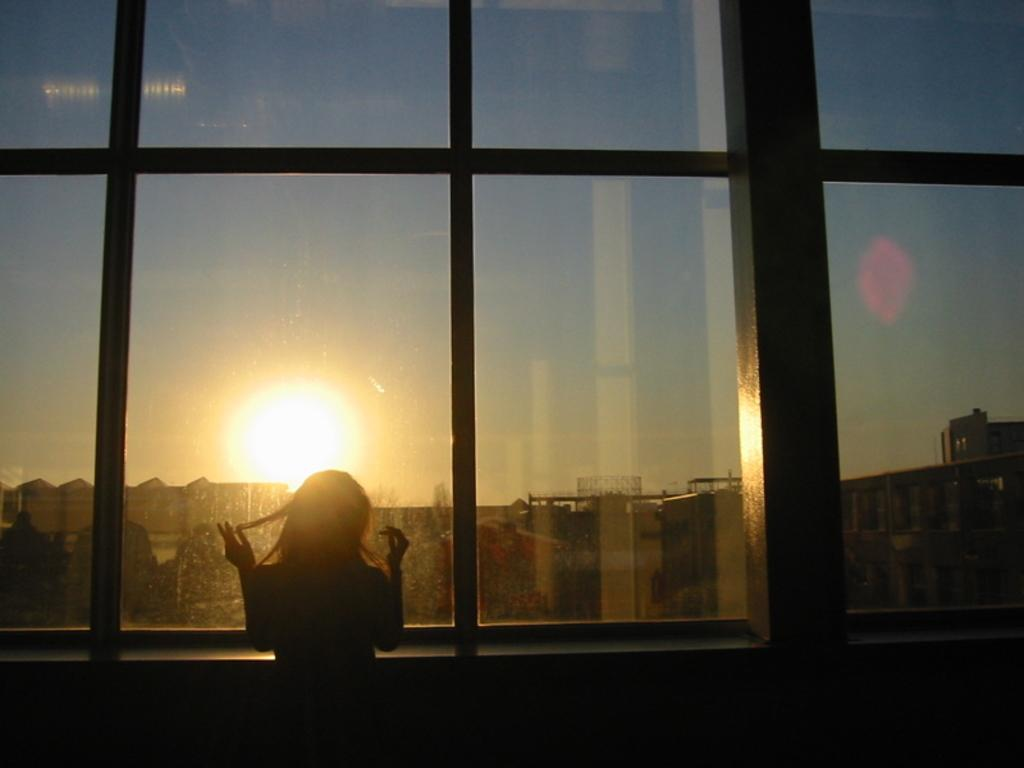What is the main subject of the image? There is a woman standing in the image. What is in front of the woman? There is a glass in front of the woman. What can be seen in the background of the image? Buildings and the sun are visible in the background. What is the rate of the system in the image? There is no system or rate present in the image; it features a woman standing with a glass in front of her, and buildings and the sun in the background. 